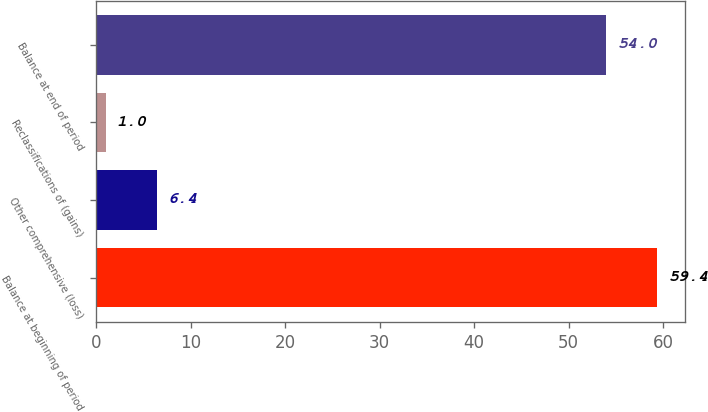<chart> <loc_0><loc_0><loc_500><loc_500><bar_chart><fcel>Balance at beginning of period<fcel>Other comprehensive (loss)<fcel>Reclassifications of (gains)<fcel>Balance at end of period<nl><fcel>59.4<fcel>6.4<fcel>1<fcel>54<nl></chart> 